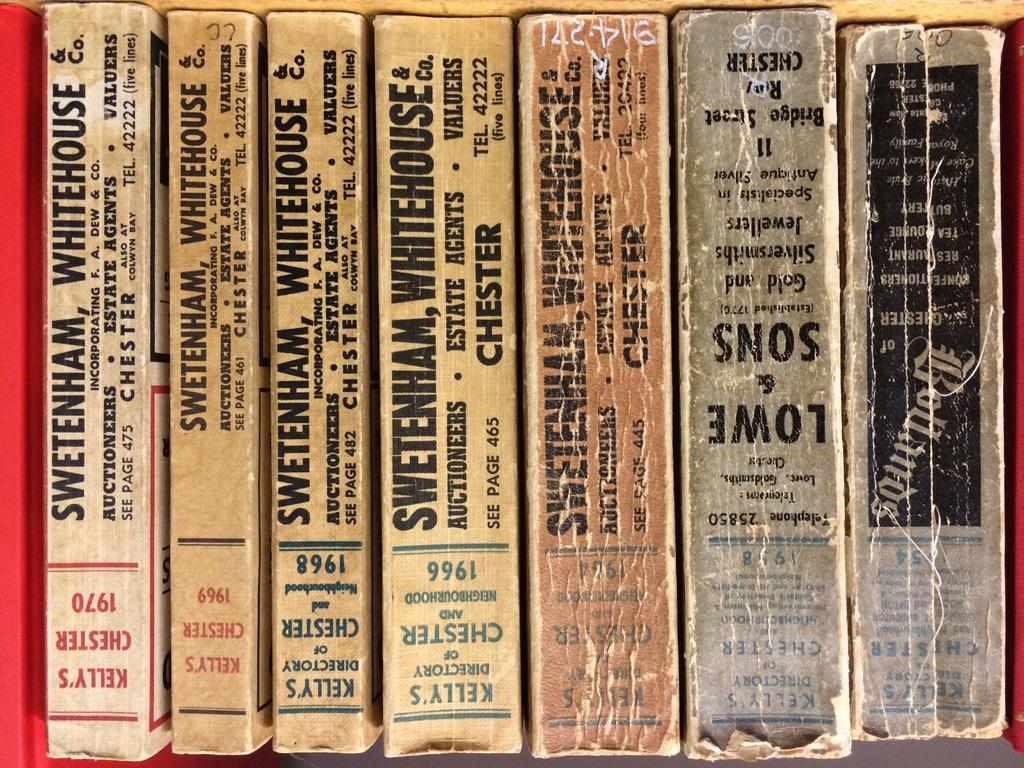<image>
Provide a brief description of the given image. Kelly's Directory of Chester from 1968 is lined up with several other old books. 